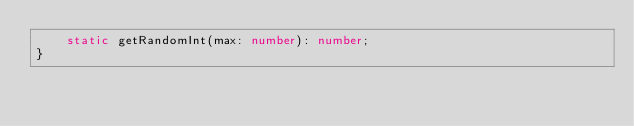Convert code to text. <code><loc_0><loc_0><loc_500><loc_500><_TypeScript_>    static getRandomInt(max: number): number;
}
</code> 